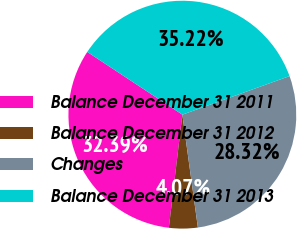<chart> <loc_0><loc_0><loc_500><loc_500><pie_chart><fcel>Balance December 31 2011<fcel>Balance December 31 2012<fcel>Changes<fcel>Balance December 31 2013<nl><fcel>32.39%<fcel>4.07%<fcel>28.32%<fcel>35.22%<nl></chart> 